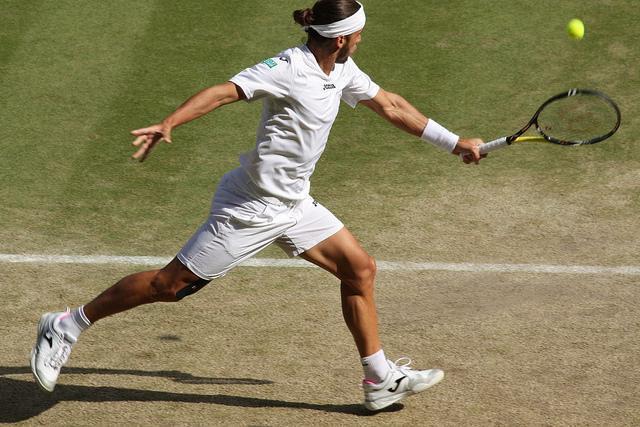What is in the man's hand?
From the following four choices, select the correct answer to address the question.
Options: Baseball bat, basketball, egg, tennis racquet. Tennis racquet. 